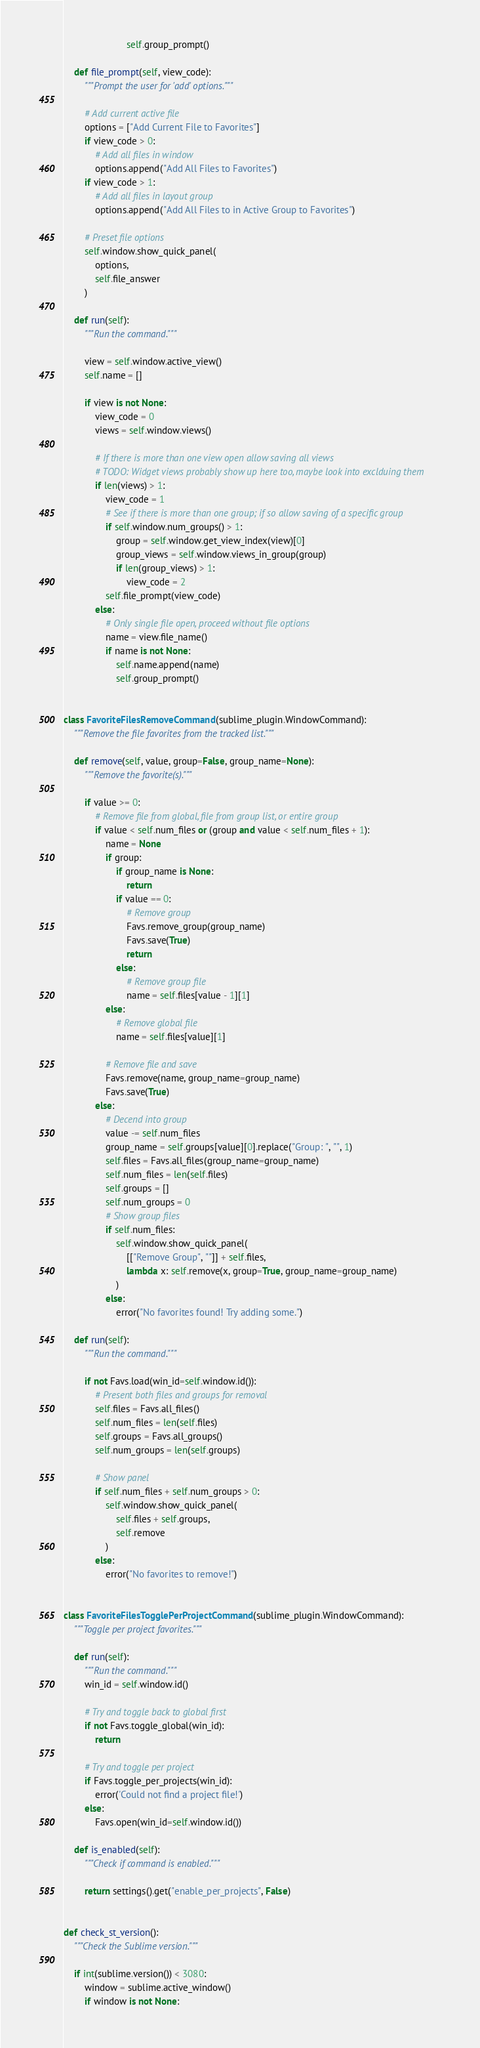Convert code to text. <code><loc_0><loc_0><loc_500><loc_500><_Python_>                        self.group_prompt()

    def file_prompt(self, view_code):
        """Prompt the user for 'add' options."""

        # Add current active file
        options = ["Add Current File to Favorites"]
        if view_code > 0:
            # Add all files in window
            options.append("Add All Files to Favorites")
        if view_code > 1:
            # Add all files in layout group
            options.append("Add All Files to in Active Group to Favorites")

        # Preset file options
        self.window.show_quick_panel(
            options,
            self.file_answer
        )

    def run(self):
        """Run the command."""

        view = self.window.active_view()
        self.name = []

        if view is not None:
            view_code = 0
            views = self.window.views()

            # If there is more than one view open allow saving all views
            # TODO: Widget views probably show up here too, maybe look into exclduing them
            if len(views) > 1:
                view_code = 1
                # See if there is more than one group; if so allow saving of a specific group
                if self.window.num_groups() > 1:
                    group = self.window.get_view_index(view)[0]
                    group_views = self.window.views_in_group(group)
                    if len(group_views) > 1:
                        view_code = 2
                self.file_prompt(view_code)
            else:
                # Only single file open, proceed without file options
                name = view.file_name()
                if name is not None:
                    self.name.append(name)
                    self.group_prompt()


class FavoriteFilesRemoveCommand(sublime_plugin.WindowCommand):
    """Remove the file favorites from the tracked list."""

    def remove(self, value, group=False, group_name=None):
        """Remove the favorite(s)."""

        if value >= 0:
            # Remove file from global, file from group list, or entire group
            if value < self.num_files or (group and value < self.num_files + 1):
                name = None
                if group:
                    if group_name is None:
                        return
                    if value == 0:
                        # Remove group
                        Favs.remove_group(group_name)
                        Favs.save(True)
                        return
                    else:
                        # Remove group file
                        name = self.files[value - 1][1]
                else:
                    # Remove global file
                    name = self.files[value][1]

                # Remove file and save
                Favs.remove(name, group_name=group_name)
                Favs.save(True)
            else:
                # Decend into group
                value -= self.num_files
                group_name = self.groups[value][0].replace("Group: ", "", 1)
                self.files = Favs.all_files(group_name=group_name)
                self.num_files = len(self.files)
                self.groups = []
                self.num_groups = 0
                # Show group files
                if self.num_files:
                    self.window.show_quick_panel(
                        [["Remove Group", ""]] + self.files,
                        lambda x: self.remove(x, group=True, group_name=group_name)
                    )
                else:
                    error("No favorites found! Try adding some.")

    def run(self):
        """Run the command."""

        if not Favs.load(win_id=self.window.id()):
            # Present both files and groups for removal
            self.files = Favs.all_files()
            self.num_files = len(self.files)
            self.groups = Favs.all_groups()
            self.num_groups = len(self.groups)

            # Show panel
            if self.num_files + self.num_groups > 0:
                self.window.show_quick_panel(
                    self.files + self.groups,
                    self.remove
                )
            else:
                error("No favorites to remove!")


class FavoriteFilesTogglePerProjectCommand(sublime_plugin.WindowCommand):
    """Toggle per project favorites."""

    def run(self):
        """Run the command."""
        win_id = self.window.id()

        # Try and toggle back to global first
        if not Favs.toggle_global(win_id):
            return

        # Try and toggle per project
        if Favs.toggle_per_projects(win_id):
            error('Could not find a project file!')
        else:
            Favs.open(win_id=self.window.id())

    def is_enabled(self):
        """Check if command is enabled."""

        return settings().get("enable_per_projects", False)


def check_st_version():
    """Check the Sublime version."""

    if int(sublime.version()) < 3080:
        window = sublime.active_window()
        if window is not None:</code> 